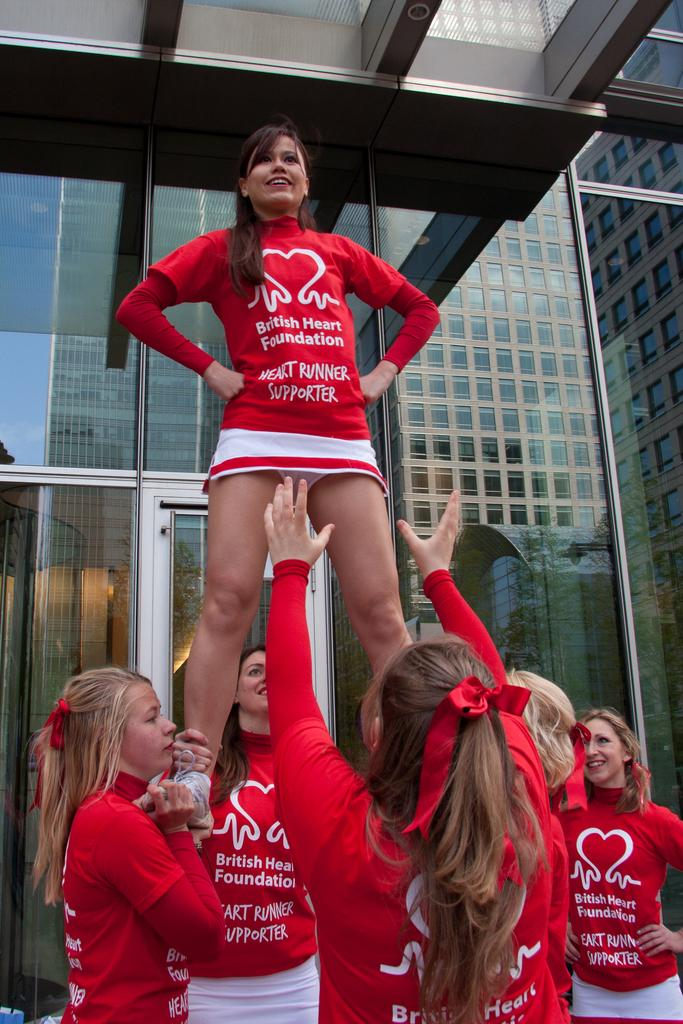<image>
Write a terse but informative summary of the picture. Several young women in red shirts that says British Heart Foundation. 